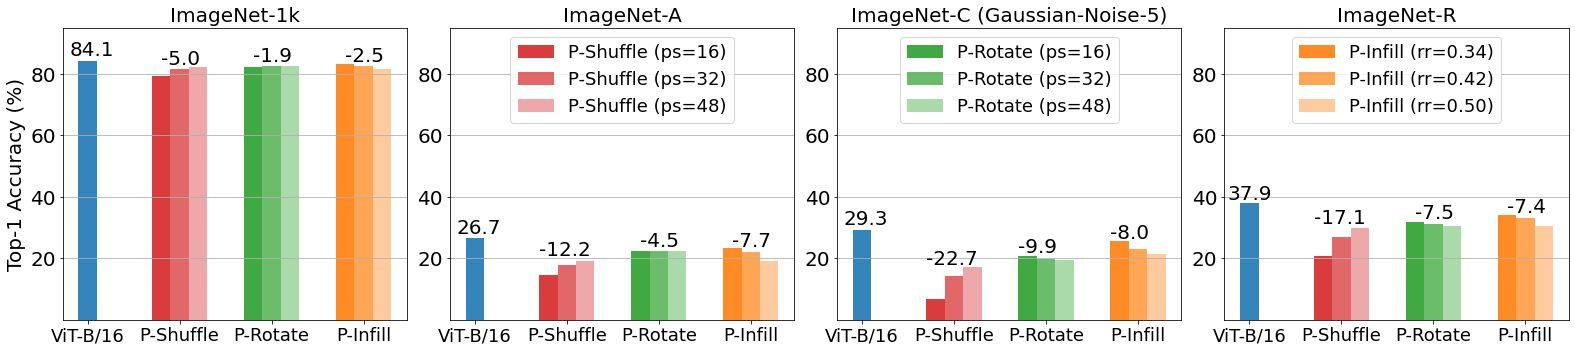Which perturbation technique results in the least performance degradation for ViT-B/16 on ImageNet-C with Gaussian-Noise-5? A) P-Shuffle with ps=16 B) P-Rotate with ps=32 C) P-Rotate with ps=16 D) P-Infill with rr=0.50 According to the data presented in the graph, the perturbation technique 'P-Rotate with a partition size (ps) of 16' leads to the most minimal decrease in the top-1 accuracy for the Vision Transformer B/16 (ViT-B/16) on ImageNet-C under the Gaussian-Noise-5 condition. Other tested methods, including P-Shuffle and P-Infill with different settings, show significantly larger impacts on accuracy. Therefore, the most effective option to maintain high performance under these specific conditions is C) P-Rotate with ps=16. 